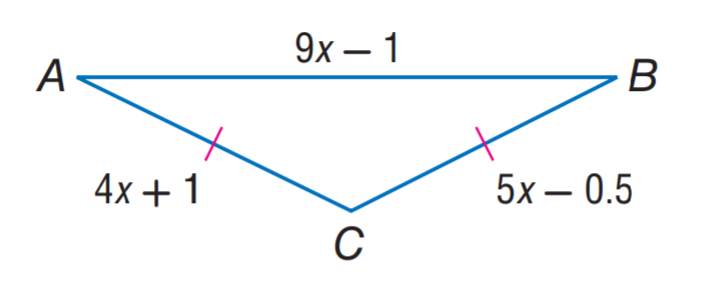Answer the mathemtical geometry problem and directly provide the correct option letter.
Question: Find the length of A B in the isosceles triangle A B C.
Choices: A: 1.5 B: 7 C: 11 D: 12.5 D 